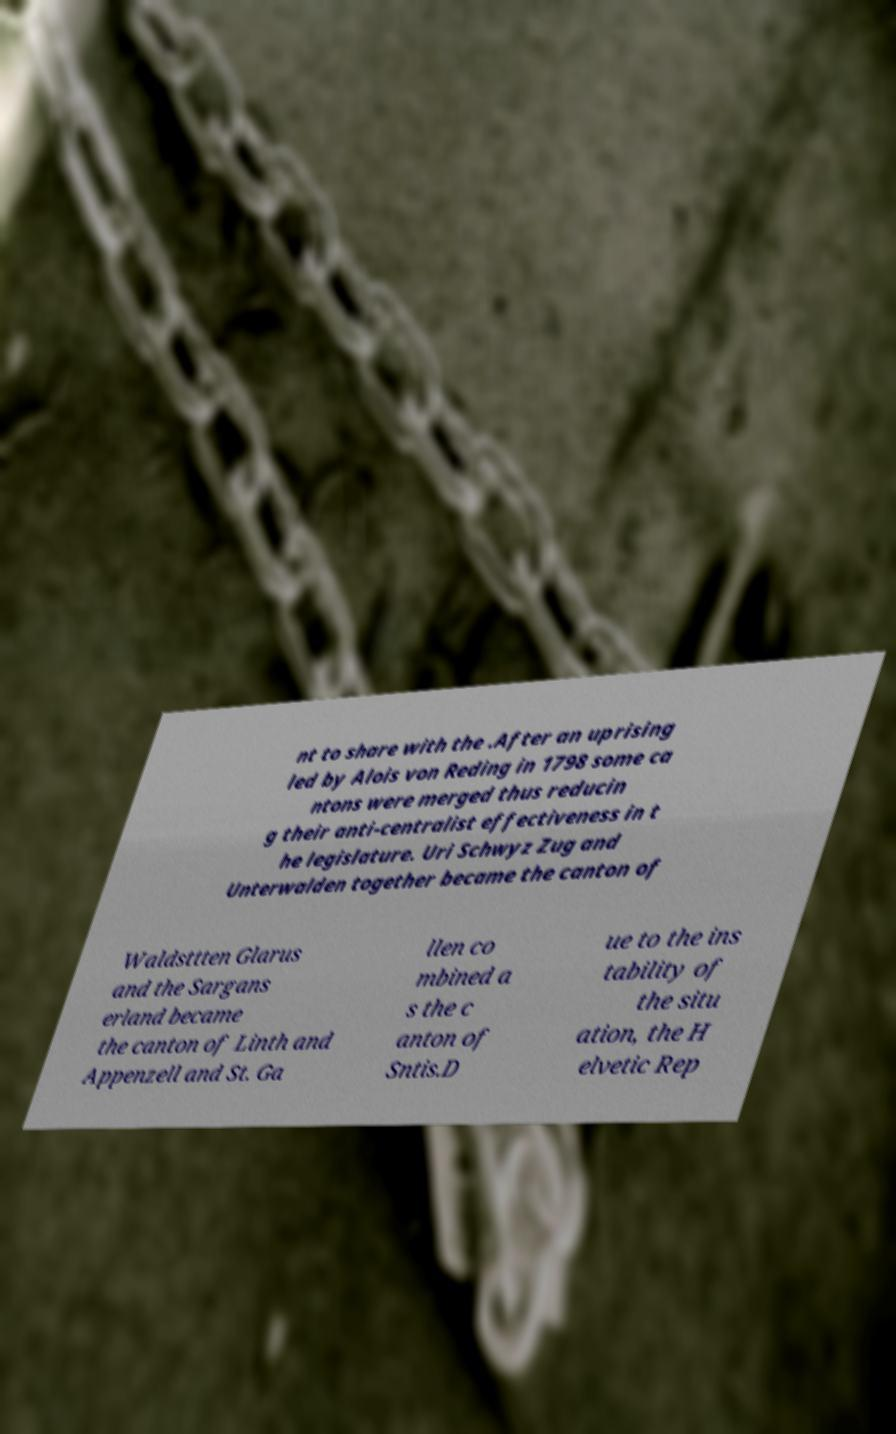What messages or text are displayed in this image? I need them in a readable, typed format. nt to share with the .After an uprising led by Alois von Reding in 1798 some ca ntons were merged thus reducin g their anti-centralist effectiveness in t he legislature. Uri Schwyz Zug and Unterwalden together became the canton of Waldsttten Glarus and the Sargans erland became the canton of Linth and Appenzell and St. Ga llen co mbined a s the c anton of Sntis.D ue to the ins tability of the situ ation, the H elvetic Rep 